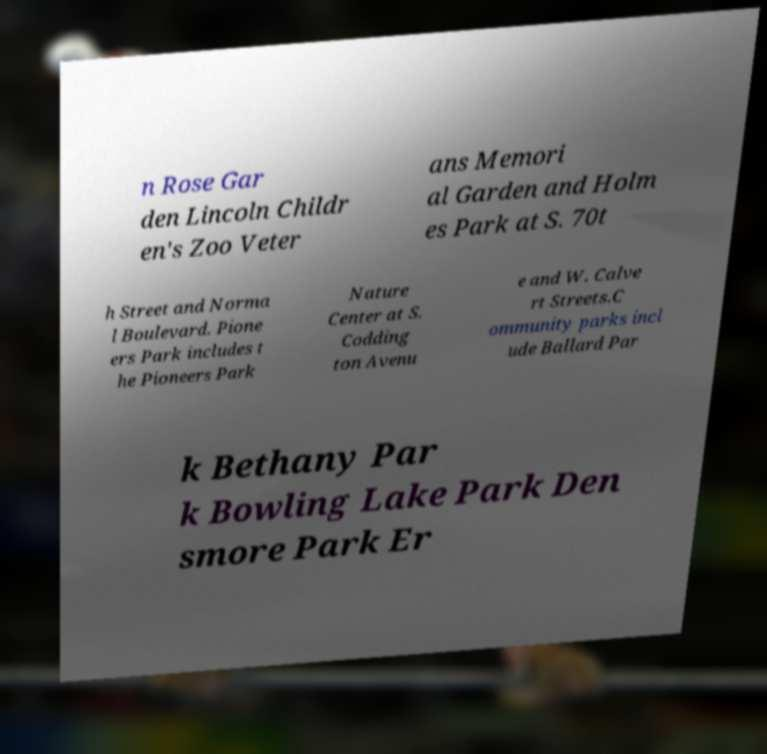Please identify and transcribe the text found in this image. n Rose Gar den Lincoln Childr en's Zoo Veter ans Memori al Garden and Holm es Park at S. 70t h Street and Norma l Boulevard. Pione ers Park includes t he Pioneers Park Nature Center at S. Codding ton Avenu e and W. Calve rt Streets.C ommunity parks incl ude Ballard Par k Bethany Par k Bowling Lake Park Den smore Park Er 